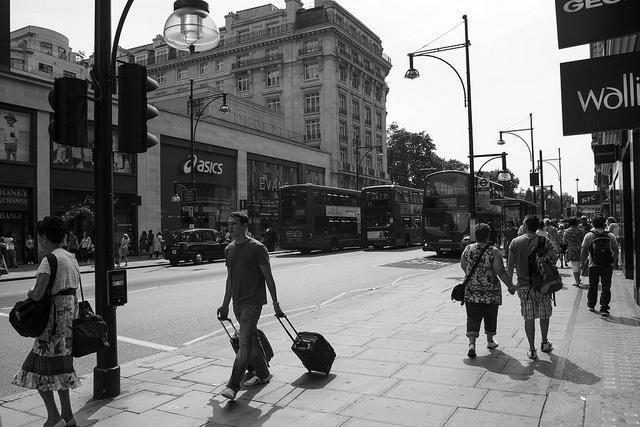How many people are holding a surfboard?
Give a very brief answer. 0. How many people can be seen?
Give a very brief answer. 6. How many buses are there?
Give a very brief answer. 3. How many traffic lights are in the photo?
Give a very brief answer. 2. 